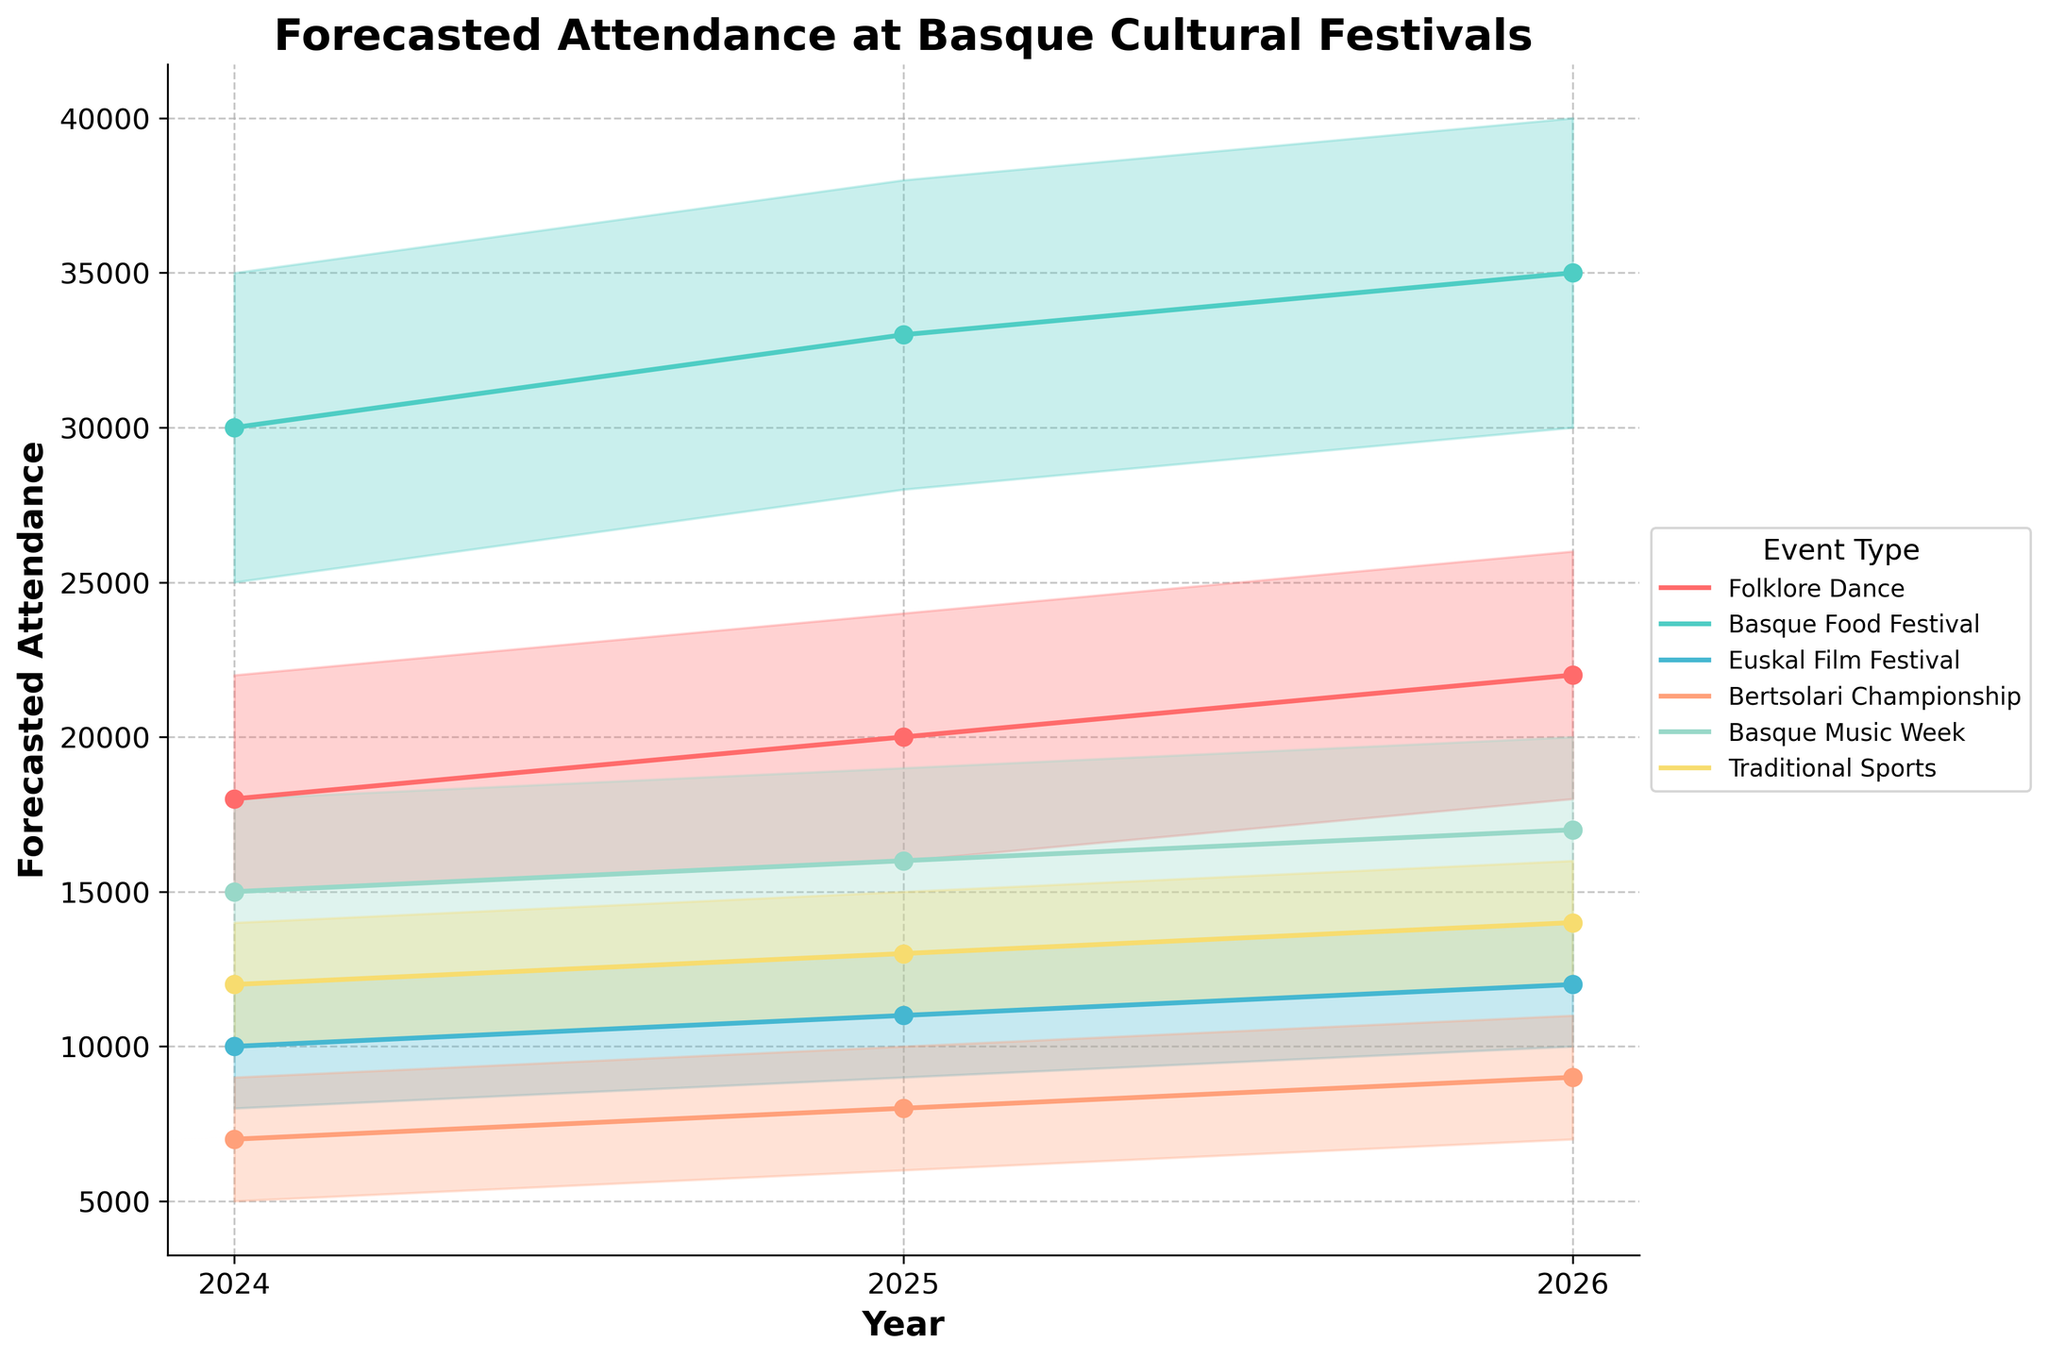What's the title of the chart? The title of the chart is located at the top of the figure in bold text.
Answer: Forecasted Attendance at Basque Cultural Festivals Which event type is forecasted to have the highest attendance in 2026? To find the event type with the highest attendance, look at the '2026 High' values for each event type on the y-axis and find the maximum value.
Answer: Basque Food Festival What is the likely attendance for the Bertsolari Championship in 2025? Locate the curve labeled "Bertsolari Championship" and identify the 'likely' attendance for the year 2025 on the x-axis.
Answer: 8,000 Compare the expected high attendance of the Traditional Sports event between 2024 and 2026. How much growth is forecasted? Look at the '2024 High' and '2026 High' values for the Traditional Sports event, then subtract the 2024 value from the 2026 value.
Answer: 2,000 What is the range of forecasted attendance for the Euskal Film Festival in 2024? Identify the 'low' and 'high' attendance values for the Euskal Film Festival in 2024, then subtract the low value from the high value.
Answer: 4,000 Which event type is forecasted to have the lowest attendance in 2025? To find the event type with the lowest attendance, look at the '2025 Low' values for each event type on the y-axis and find the minimum value.
Answer: Bertsolari Championship How does the attendance forecast for Basque Music Week change from 2024 to 2026? Locate the Basque Music Week attendance on the y-axis and compare the 'likely' values for 2024, 2025, and 2026. Note the increase for each year.
Answer: Increases Which city is hosting the Folklore Dance event? Look at the information in the legend or within the data labels to find the city associated with the Folklore Dance event.
Answer: Bilbao Among all events, which one shows the most significant increase in 'likely' attendance from 2024 to 2026? Compare the 'likely' values for 2024 and 2026 across all events and determine which event has the largest difference.
Answer: Basque Food Festival What's the likely combined attendance of all events in 2024? Sum the '2024 Likely' attendance values for each event type.
Answer: 92,000 